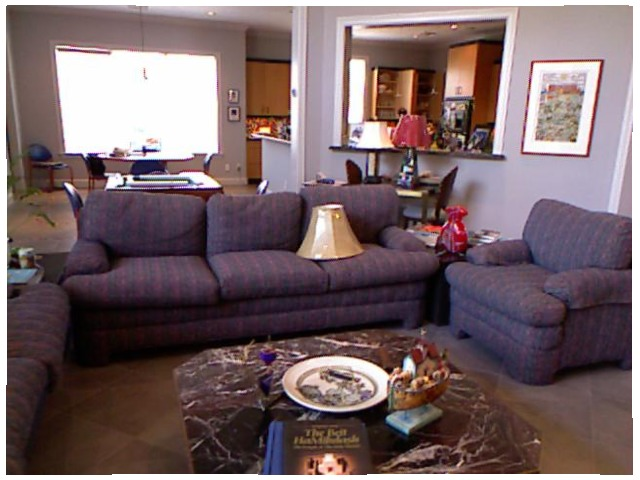<image>
Can you confirm if the couch is under the lamp shade? Yes. The couch is positioned underneath the lamp shade, with the lamp shade above it in the vertical space. Where is the book in relation to the table? Is it on the table? Yes. Looking at the image, I can see the book is positioned on top of the table, with the table providing support. Is the lamp shade on the couch? Yes. Looking at the image, I can see the lamp shade is positioned on top of the couch, with the couch providing support. Is there a lamp shade on the wall? No. The lamp shade is not positioned on the wall. They may be near each other, but the lamp shade is not supported by or resting on top of the wall. Where is the lamp in relation to the table? Is it on the table? No. The lamp is not positioned on the table. They may be near each other, but the lamp is not supported by or resting on top of the table. Is the lamp on the table? No. The lamp is not positioned on the table. They may be near each other, but the lamp is not supported by or resting on top of the table. Where is the couch in relation to the lamp shade? Is it on the lamp shade? No. The couch is not positioned on the lamp shade. They may be near each other, but the couch is not supported by or resting on top of the lamp shade. Is the plate behind the book? Yes. From this viewpoint, the plate is positioned behind the book, with the book partially or fully occluding the plate. Where is the lamp shade in relation to the plate? Is it above the plate? No. The lamp shade is not positioned above the plate. The vertical arrangement shows a different relationship. 